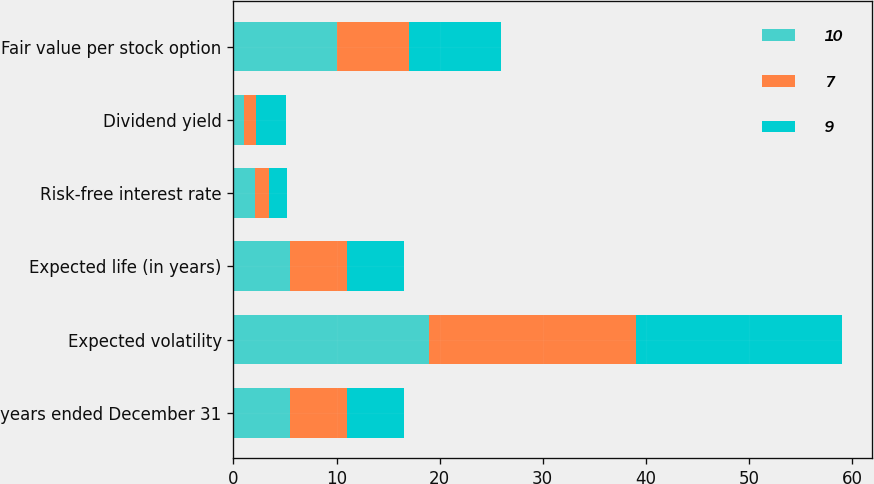Convert chart to OTSL. <chart><loc_0><loc_0><loc_500><loc_500><stacked_bar_chart><ecel><fcel>years ended December 31<fcel>Expected volatility<fcel>Expected life (in years)<fcel>Risk-free interest rate<fcel>Dividend yield<fcel>Fair value per stock option<nl><fcel>10<fcel>5.5<fcel>19<fcel>5.5<fcel>2.1<fcel>1<fcel>10<nl><fcel>7<fcel>5.5<fcel>20<fcel>5.5<fcel>1.4<fcel>1.2<fcel>7<nl><fcel>9<fcel>5.5<fcel>20<fcel>5.5<fcel>1.7<fcel>2.9<fcel>9<nl></chart> 